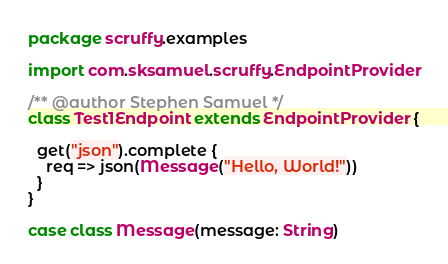<code> <loc_0><loc_0><loc_500><loc_500><_Scala_>package scruffy.examples

import com.sksamuel.scruffy.EndpointProvider

/** @author Stephen Samuel */
class Test1Endpoint extends EndpointProvider {

  get("json").complete {
    req => json(Message("Hello, World!"))
  }
}

case class Message(message: String)</code> 